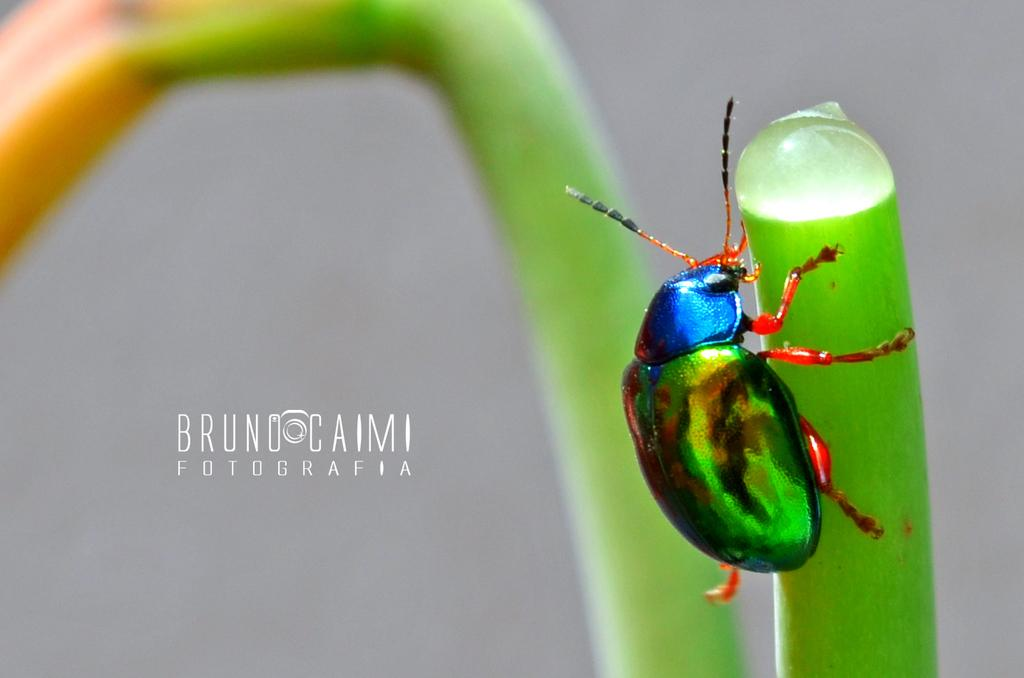What type of creature can be seen in the image? There is an insect in the image. How would you describe the background of the image? The background of the image is blurry. What else is present in the middle of the image besides the insect? There is some text in the middle of the image. What type of pie is being advertised by the company in the image? There is no pie or company present in the image; it only features an insect and some text. 